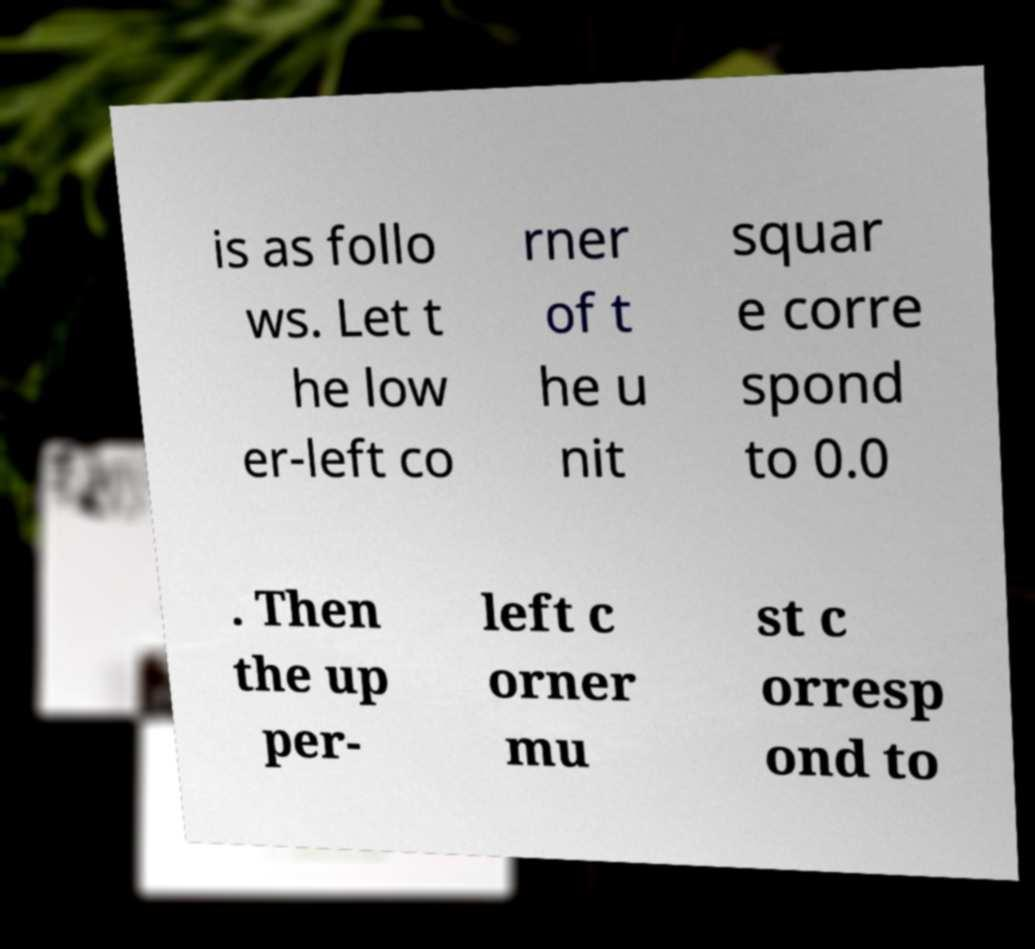Can you read and provide the text displayed in the image?This photo seems to have some interesting text. Can you extract and type it out for me? is as follo ws. Let t he low er-left co rner of t he u nit squar e corre spond to 0.0 . Then the up per- left c orner mu st c orresp ond to 